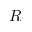<formula> <loc_0><loc_0><loc_500><loc_500>R</formula> 